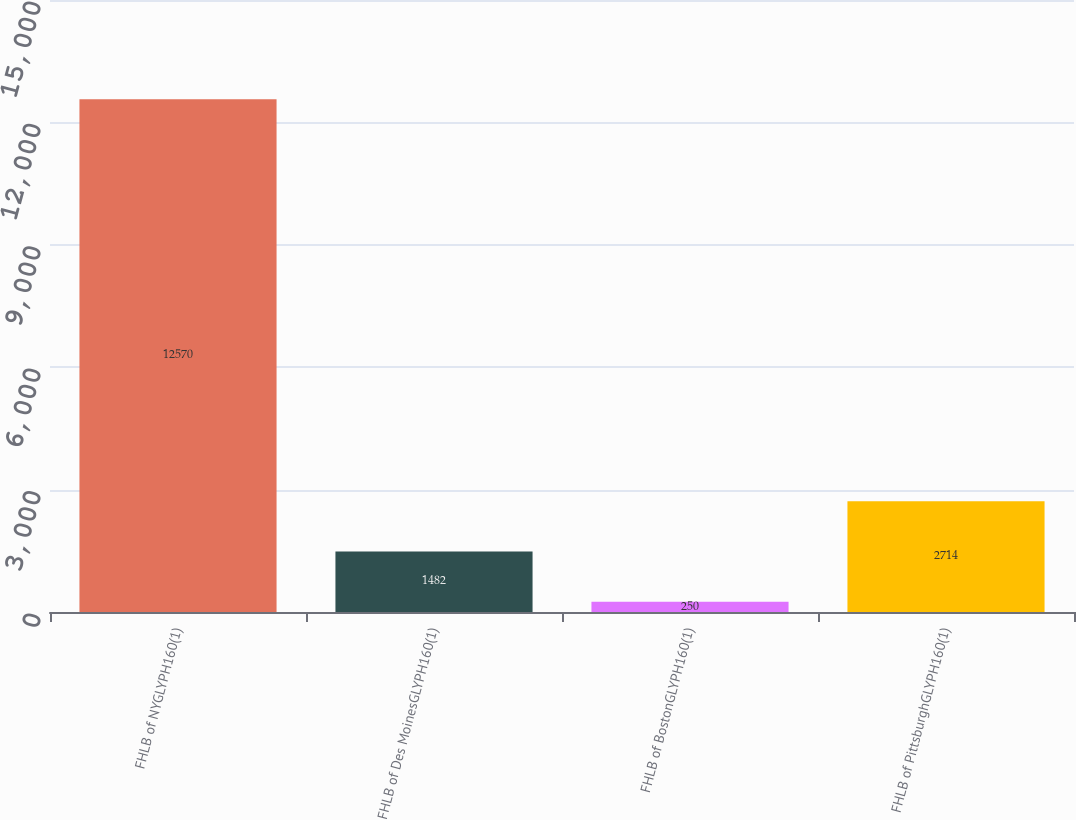Convert chart. <chart><loc_0><loc_0><loc_500><loc_500><bar_chart><fcel>FHLB of NYGLYPH160(1)<fcel>FHLB of Des MoinesGLYPH160(1)<fcel>FHLB of BostonGLYPH160(1)<fcel>FHLB of PittsburghGLYPH160(1)<nl><fcel>12570<fcel>1482<fcel>250<fcel>2714<nl></chart> 